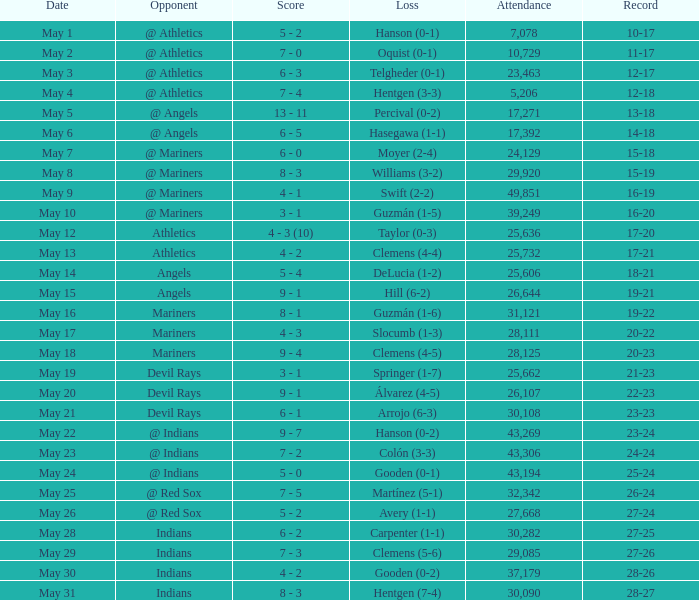When was the record 27-25? May 28. 